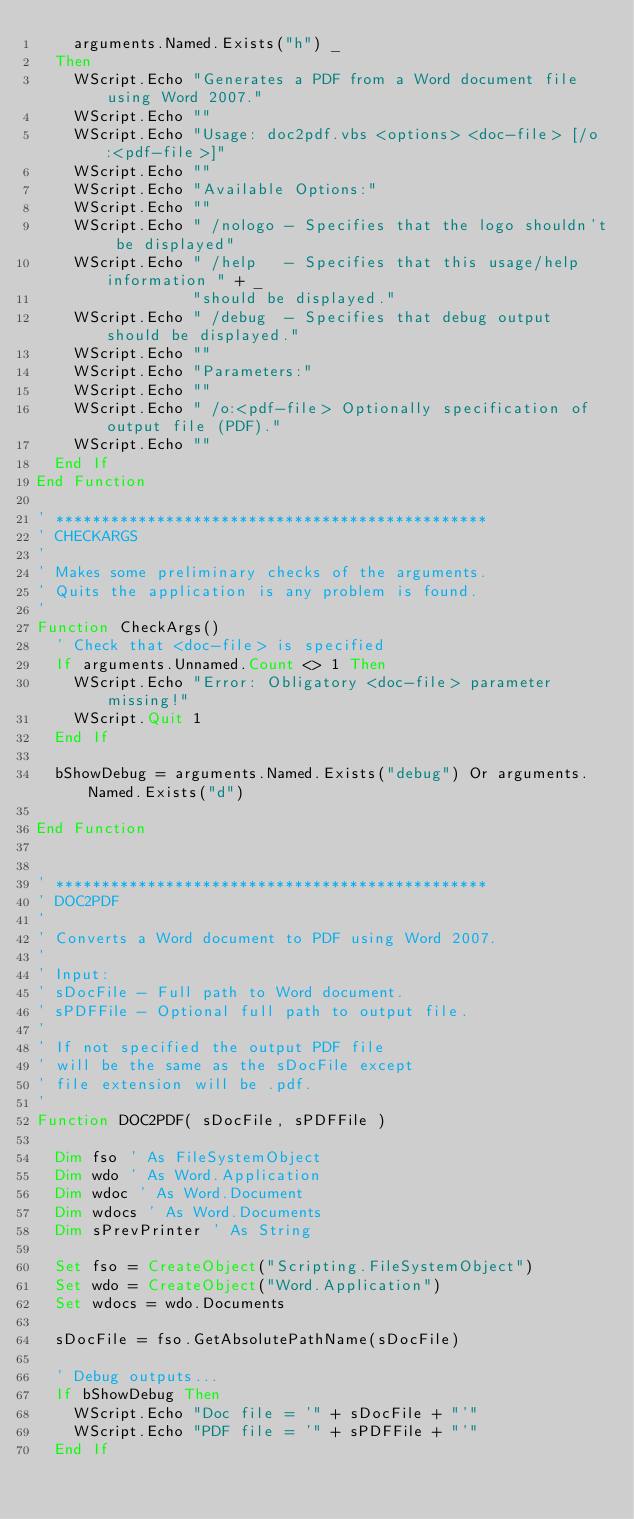<code> <loc_0><loc_0><loc_500><loc_500><_VisualBasic_>    arguments.Named.Exists("h") _
  Then
    WScript.Echo "Generates a PDF from a Word document file using Word 2007."
    WScript.Echo ""
    WScript.Echo "Usage: doc2pdf.vbs <options> <doc-file> [/o:<pdf-file>]"
    WScript.Echo ""
    WScript.Echo "Available Options:"
    WScript.Echo ""
    WScript.Echo " /nologo - Specifies that the logo shouldn't be displayed"
    WScript.Echo " /help   - Specifies that this usage/help information " + _
                 "should be displayed."
    WScript.Echo " /debug  - Specifies that debug output should be displayed."
    WScript.Echo ""
    WScript.Echo "Parameters:"
    WScript.Echo ""
    WScript.Echo " /o:<pdf-file> Optionally specification of output file (PDF)."
    WScript.Echo ""
  End If 
End Function

' ***********************************************
' CHECKARGS
'
' Makes some preliminary checks of the arguments.
' Quits the application is any problem is found.
'
Function CheckArgs()
  ' Check that <doc-file> is specified
  If arguments.Unnamed.Count <> 1 Then
    WScript.Echo "Error: Obligatory <doc-file> parameter missing!"
    WScript.Quit 1
  End If

  bShowDebug = arguments.Named.Exists("debug") Or arguments.Named.Exists("d")

End Function


' ***********************************************
' DOC2PDF
'
' Converts a Word document to PDF using Word 2007.
'
' Input:
' sDocFile - Full path to Word document.
' sPDFFile - Optional full path to output file.
'
' If not specified the output PDF file
' will be the same as the sDocFile except
' file extension will be .pdf.
'
Function DOC2PDF( sDocFile, sPDFFile )

  Dim fso ' As FileSystemObject
  Dim wdo ' As Word.Application
  Dim wdoc ' As Word.Document
  Dim wdocs ' As Word.Documents
  Dim sPrevPrinter ' As String

  Set fso = CreateObject("Scripting.FileSystemObject")
  Set wdo = CreateObject("Word.Application")
  Set wdocs = wdo.Documents

  sDocFile = fso.GetAbsolutePathName(sDocFile)

  ' Debug outputs...
  If bShowDebug Then
    WScript.Echo "Doc file = '" + sDocFile + "'"
    WScript.Echo "PDF file = '" + sPDFFile + "'"
  End If
</code> 